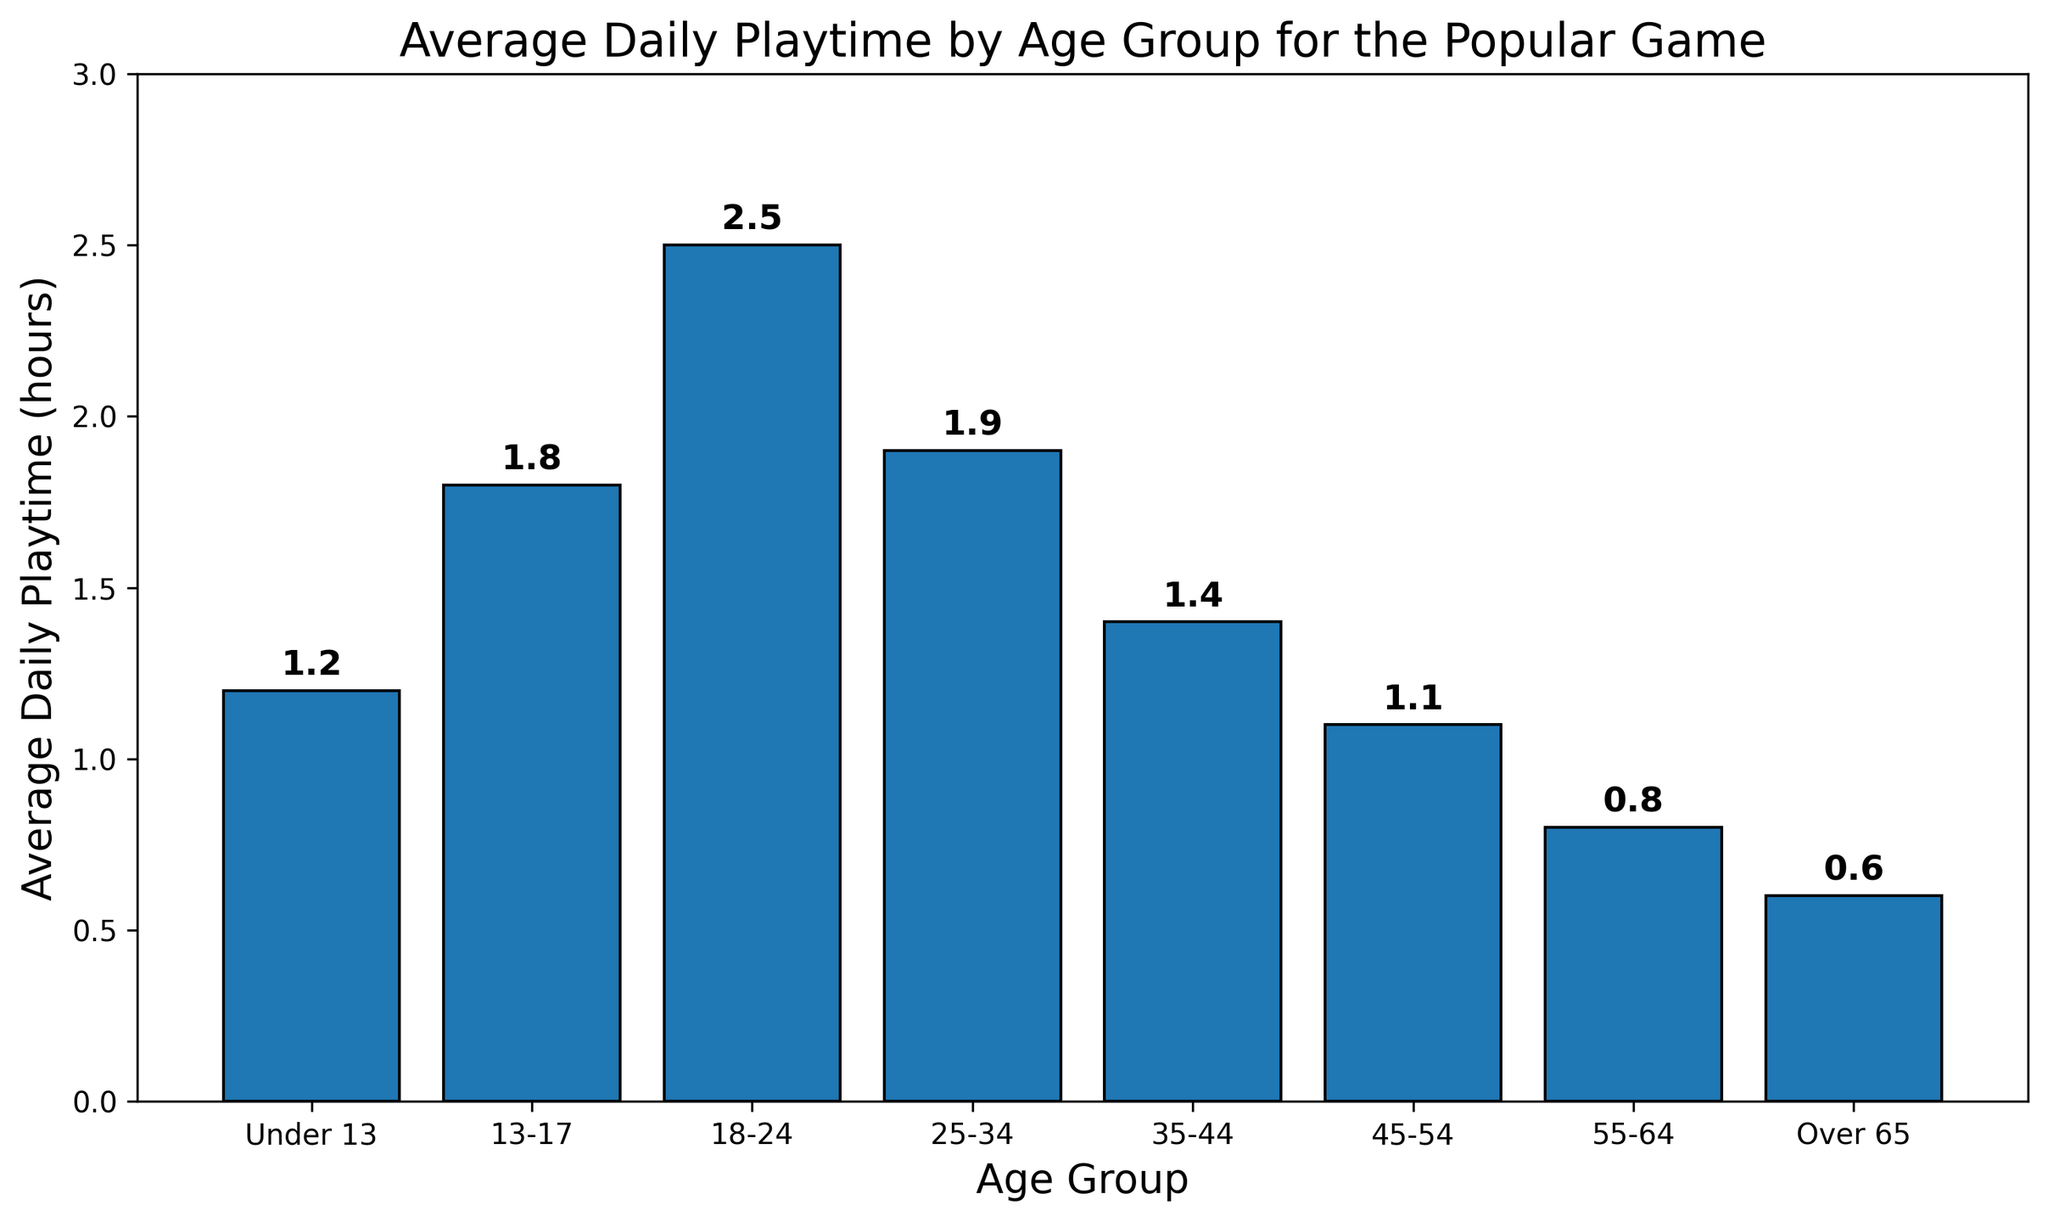What's the average daily playtime for age groups under 13 and 18-24 combined? First, find the average daily playtime for both age groups: Under 13 is 1.2 hours, and 18-24 is 2.5 hours. Then, add these values together: 1.2 + 2.5 = 3.7 hours. Finally, divide by the number of age groups, which is 2: 3.7 / 2 = 1.85 hours.
Answer: 1.85 hours Which age group has the highest average daily playtime? Look at the height of each bar. The tallest bar represents the age group with the highest average daily playtime. The 18-24 age group has the tallest bar, which corresponds to 2.5 hours.
Answer: 18-24 What is the difference in average daily playtime between the 13-17 and 45-54 age groups? Find the average daily playtime for each age group: 13-17 is 1.8 hours, and 45-54 is 1.1 hours. Subtract the smaller value from the larger one: 1.8 - 1.1 = 0.7 hours.
Answer: 0.7 hours Which age groups have an average daily playtime less than 1 hour? Identify the bars with heights less than 1 hour. The bars for age groups 55-64 (0.8 hours) and Over 65 (0.6 hours) are less than 1 hour high.
Answer: 55-64, Over 65 By how much does the average daily playtime for the 25-34 age group exceed that of the 35-44 age group? Find the average daily playtime for both age groups: 25-34 is 1.9 hours, and 35-44 is 1.4 hours. Subtract the smaller value from the larger one: 1.9 - 1.4 = 0.5 hours.
Answer: 0.5 hours What is the total average daily playtime for all age groups combined? Sum up the average daily playtime for all age groups: 1.2 + 1.8 + 2.5 + 1.9 + 1.4 + 1.1 + 0.8 + 0.6 = 11.3 hours.
Answer: 11.3 hours Which age group has the smallest average daily playtime, and what is that value? Look for the shortest bar in the chart, which represents the age group with the smallest average daily playtime. The shortest bar is for the Over 65 age group, and its height represents 0.6 hours.
Answer: Over 65, 0.6 hours How many age groups have an average daily playtime greater than 1.5 hours? Identify the bars with heights greater than 1.5 hours. The age groups are: 13-17 (1.8 hours), 18-24 (2.5 hours), and 25-34 (1.9 hours). There are 3 such age groups.
Answer: 3 